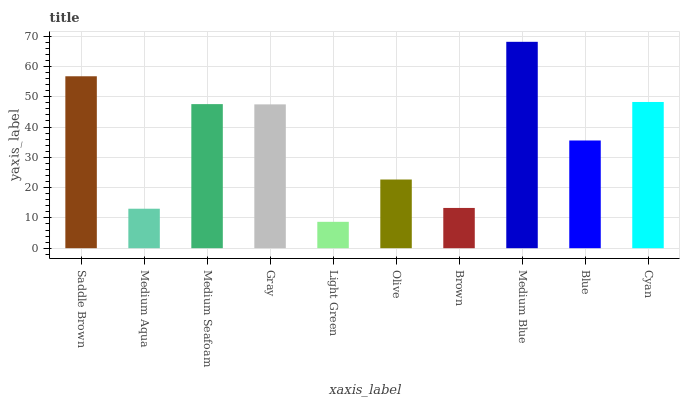Is Light Green the minimum?
Answer yes or no. Yes. Is Medium Blue the maximum?
Answer yes or no. Yes. Is Medium Aqua the minimum?
Answer yes or no. No. Is Medium Aqua the maximum?
Answer yes or no. No. Is Saddle Brown greater than Medium Aqua?
Answer yes or no. Yes. Is Medium Aqua less than Saddle Brown?
Answer yes or no. Yes. Is Medium Aqua greater than Saddle Brown?
Answer yes or no. No. Is Saddle Brown less than Medium Aqua?
Answer yes or no. No. Is Gray the high median?
Answer yes or no. Yes. Is Blue the low median?
Answer yes or no. Yes. Is Medium Aqua the high median?
Answer yes or no. No. Is Cyan the low median?
Answer yes or no. No. 